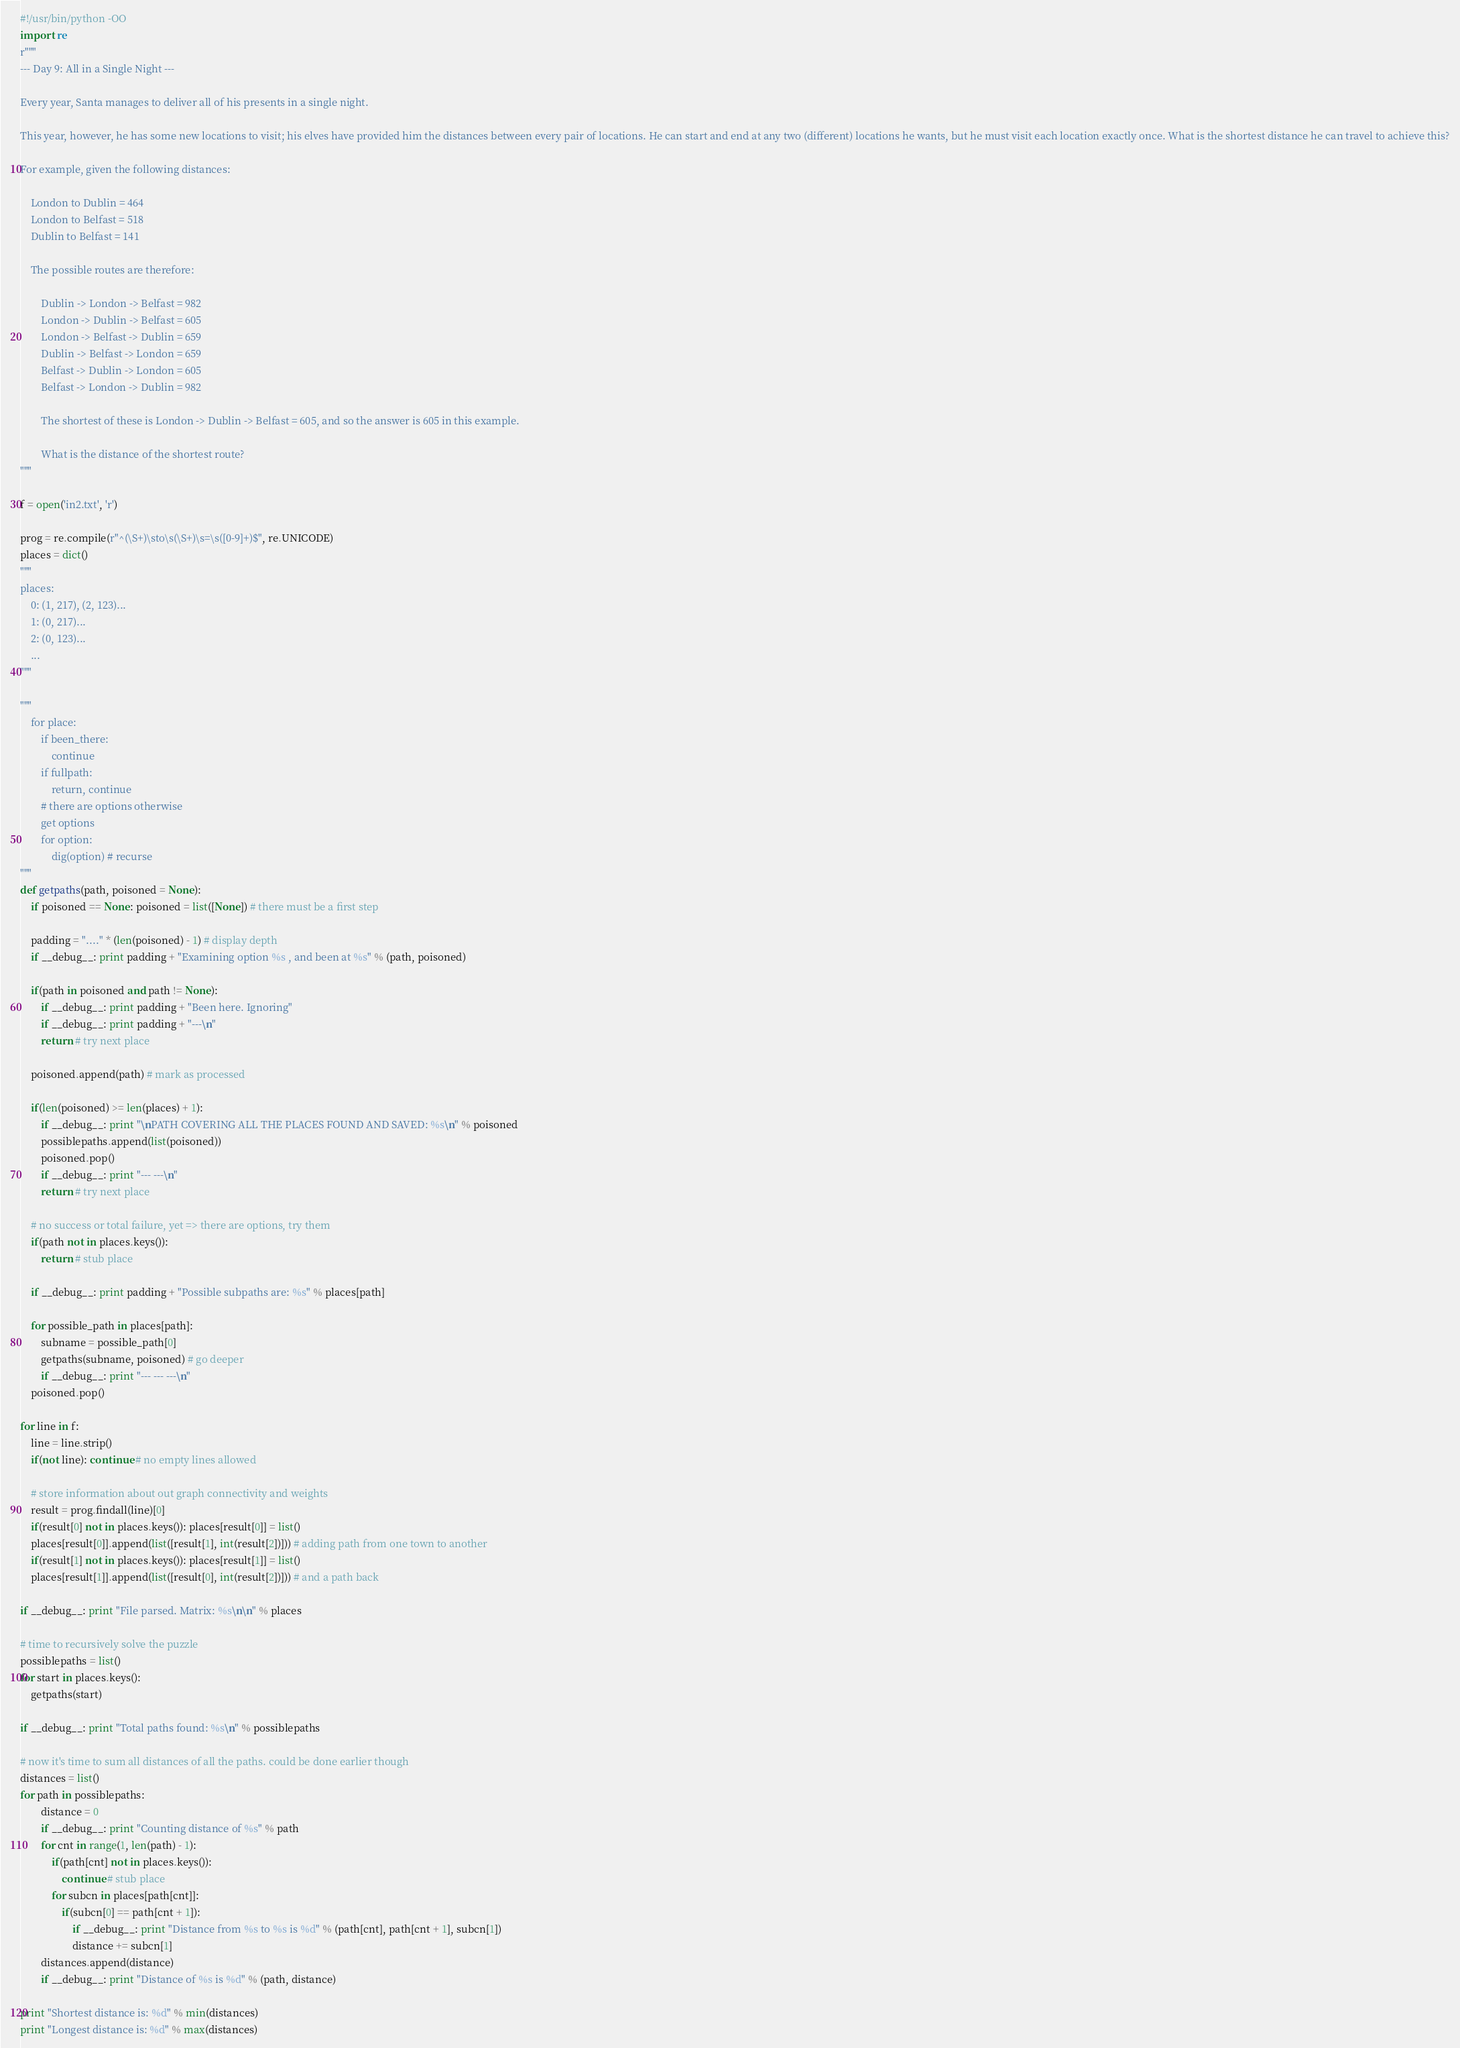<code> <loc_0><loc_0><loc_500><loc_500><_Python_>#!/usr/bin/python -OO
import re
r"""
--- Day 9: All in a Single Night ---

Every year, Santa manages to deliver all of his presents in a single night.

This year, however, he has some new locations to visit; his elves have provided him the distances between every pair of locations. He can start and end at any two (different) locations he wants, but he must visit each location exactly once. What is the shortest distance he can travel to achieve this?

For example, given the following distances:

	London to Dublin = 464
	London to Belfast = 518
	Dublin to Belfast = 141

	The possible routes are therefore:

		Dublin -> London -> Belfast = 982
		London -> Dublin -> Belfast = 605
		London -> Belfast -> Dublin = 659
		Dublin -> Belfast -> London = 659
		Belfast -> Dublin -> London = 605
		Belfast -> London -> Dublin = 982

		The shortest of these is London -> Dublin -> Belfast = 605, and so the answer is 605 in this example.

		What is the distance of the shortest route?
"""

f = open('in2.txt', 'r')

prog = re.compile(r"^(\S+)\sto\s(\S+)\s=\s([0-9]+)$", re.UNICODE)
places = dict()
"""
places:
	0: (1, 217), (2, 123)...
	1: (0, 217)...
	2: (0, 123)...
	...
"""

"""
	for place:
		if been_there:
			continue
		if fullpath:
			return, continue
		# there are options otherwise
		get options
		for option:
			dig(option) # recurse
"""
def getpaths(path, poisoned = None):
	if poisoned == None: poisoned = list([None]) # there must be a first step

	padding = "...." * (len(poisoned) - 1) # display depth
	if __debug__: print padding + "Examining option %s , and been at %s" % (path, poisoned)

	if(path in poisoned and path != None):
		if __debug__: print padding + "Been here. Ignoring"
		if __debug__: print padding + "---\n"
		return # try next place

	poisoned.append(path) # mark as processed

	if(len(poisoned) >= len(places) + 1):
		if __debug__: print "\nPATH COVERING ALL THE PLACES FOUND AND SAVED: %s\n" % poisoned
		possiblepaths.append(list(poisoned))
		poisoned.pop()
		if __debug__: print "--- ---\n"
		return # try next place

	# no success or total failure, yet => there are options, try them
	if(path not in places.keys()):
		return # stub place

	if __debug__: print padding + "Possible subpaths are: %s" % places[path]

	for possible_path in places[path]:
		subname = possible_path[0]
		getpaths(subname, poisoned) # go deeper
		if __debug__: print "--- --- ---\n"
	poisoned.pop()

for line in f:
	line = line.strip()
	if(not line): continue # no empty lines allowed

	# store information about out graph connectivity and weights
	result = prog.findall(line)[0]
	if(result[0] not in places.keys()): places[result[0]] = list()
	places[result[0]].append(list([result[1], int(result[2])])) # adding path from one town to another
	if(result[1] not in places.keys()): places[result[1]] = list()
	places[result[1]].append(list([result[0], int(result[2])])) # and a path back

if __debug__: print "File parsed. Matrix: %s\n\n" % places

# time to recursively solve the puzzle
possiblepaths = list()
for start in places.keys():
	getpaths(start)

if __debug__: print "Total paths found: %s\n" % possiblepaths

# now it's time to sum all distances of all the paths. could be done earlier though
distances = list()
for path in possiblepaths:
		distance = 0
		if __debug__: print "Counting distance of %s" % path
		for cnt in range(1, len(path) - 1):
			if(path[cnt] not in places.keys()):
				continue # stub place
			for subcn in places[path[cnt]]:
				if(subcn[0] == path[cnt + 1]):
					if __debug__: print "Distance from %s to %s is %d" % (path[cnt], path[cnt + 1], subcn[1])
					distance += subcn[1]
		distances.append(distance)
		if __debug__: print "Distance of %s is %d" % (path, distance)

print "Shortest distance is: %d" % min(distances)
print "Longest distance is: %d" % max(distances)
</code> 